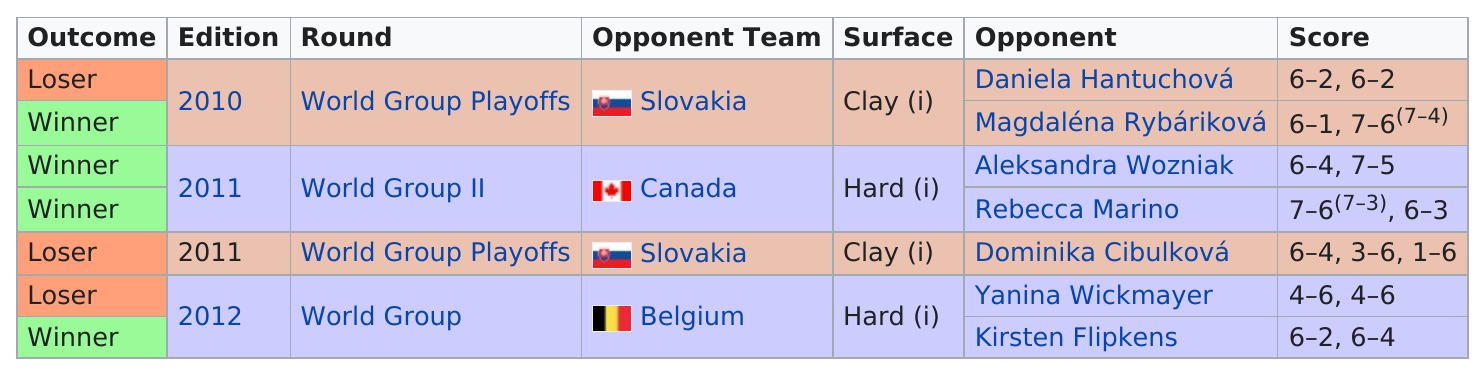Point out several critical features in this image. Slovakia played in another year besides 2010, which was 2011. The next game on the schedule after the World Group II rounds was the World Group Playoffs. Did they beat Canada in more or less than 3 matches? The answer is clear: less. The game versus Canada was not later than the game versus Belgium. The World Group Playoffs did not feature any playoff rounds that were played on hard surfaces. 